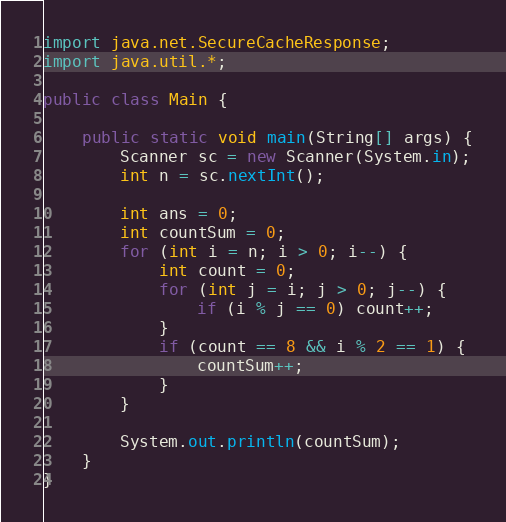<code> <loc_0><loc_0><loc_500><loc_500><_Java_>import java.net.SecureCacheResponse;
import java.util.*;

public class Main {

    public static void main(String[] args) {
        Scanner sc = new Scanner(System.in);
        int n = sc.nextInt();

        int ans = 0;
        int countSum = 0;
        for (int i = n; i > 0; i--) {
            int count = 0;
            for (int j = i; j > 0; j--) {
                if (i % j == 0) count++;
            }
            if (count == 8 && i % 2 == 1) {
                countSum++;
            }
        }

        System.out.println(countSum);
    }
}
</code> 